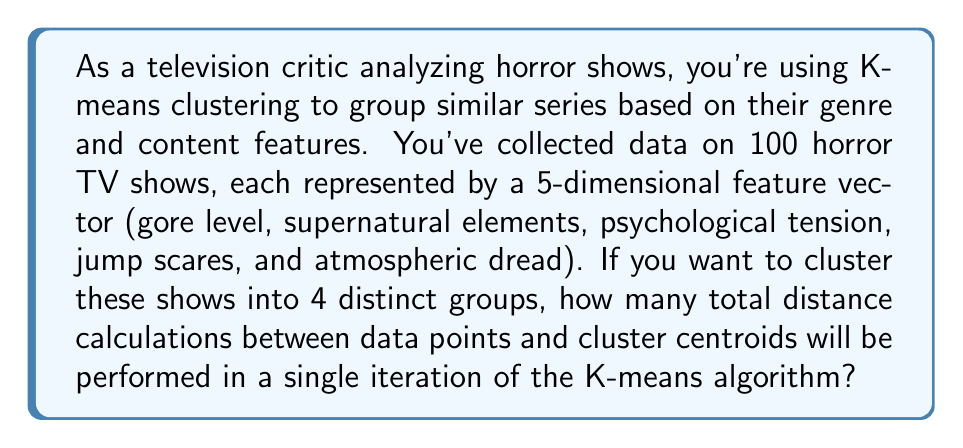Give your solution to this math problem. To solve this problem, let's break it down step-by-step:

1. We're using K-means clustering with the following parameters:
   - $n$ = 100 (number of data points / TV shows)
   - $k$ = 4 (number of clusters)
   - $d$ = 5 (number of dimensions in each feature vector)

2. In each iteration of K-means, we need to calculate the distance between each data point and each cluster centroid.

3. The number of distance calculations per iteration is:
   $$ \text{Number of calculations} = n \times k $$

4. In this case:
   $$ \text{Number of calculations} = 100 \times 4 = 400 $$

5. It's important to note that each of these 400 calculations involves computing the distance in 5-dimensional space, but we're only asked for the total number of distance calculations, not the computational complexity of each calculation.

This approach ensures that every TV show is compared to each cluster centroid in every iteration, allowing the algorithm to assign each show to the nearest cluster and update the centroids accordingly.
Answer: 400 distance calculations 